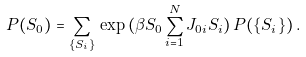<formula> <loc_0><loc_0><loc_500><loc_500>P ( S _ { 0 } ) = \sum _ { \{ S _ { i } \} } \, \exp { ( \beta S _ { 0 } \sum _ { i = 1 } ^ { N } J _ { 0 i } S _ { i } ) } \, P ( \{ S _ { i } \} ) \, .</formula> 